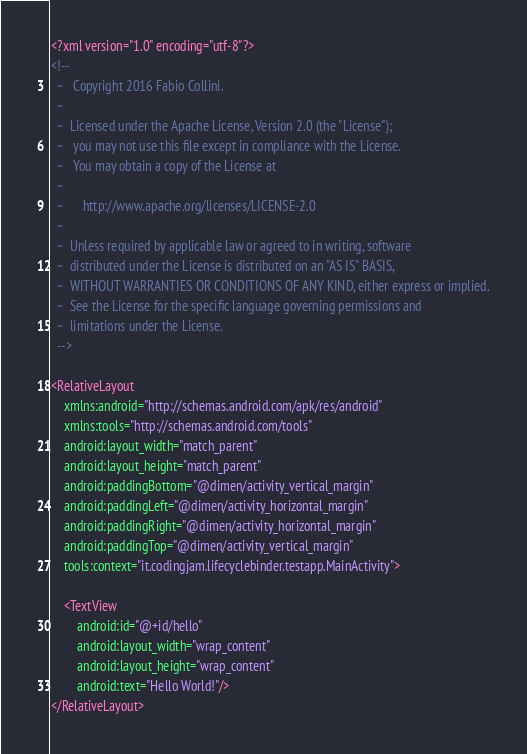<code> <loc_0><loc_0><loc_500><loc_500><_XML_><?xml version="1.0" encoding="utf-8"?>
<!--
  ~   Copyright 2016 Fabio Collini.
  ~
  ~  Licensed under the Apache License, Version 2.0 (the "License");
  ~   you may not use this file except in compliance with the License.
  ~   You may obtain a copy of the License at
  ~
  ~      http://www.apache.org/licenses/LICENSE-2.0
  ~
  ~  Unless required by applicable law or agreed to in writing, software
  ~  distributed under the License is distributed on an "AS IS" BASIS,
  ~  WITHOUT WARRANTIES OR CONDITIONS OF ANY KIND, either express or implied.
  ~  See the License for the specific language governing permissions and
  ~  limitations under the License.
  -->

<RelativeLayout
    xmlns:android="http://schemas.android.com/apk/res/android"
    xmlns:tools="http://schemas.android.com/tools"
    android:layout_width="match_parent"
    android:layout_height="match_parent"
    android:paddingBottom="@dimen/activity_vertical_margin"
    android:paddingLeft="@dimen/activity_horizontal_margin"
    android:paddingRight="@dimen/activity_horizontal_margin"
    android:paddingTop="@dimen/activity_vertical_margin"
    tools:context="it.codingjam.lifecyclebinder.testapp.MainActivity">

    <TextView
        android:id="@+id/hello"
        android:layout_width="wrap_content"
        android:layout_height="wrap_content"
        android:text="Hello World!"/>
</RelativeLayout>
</code> 